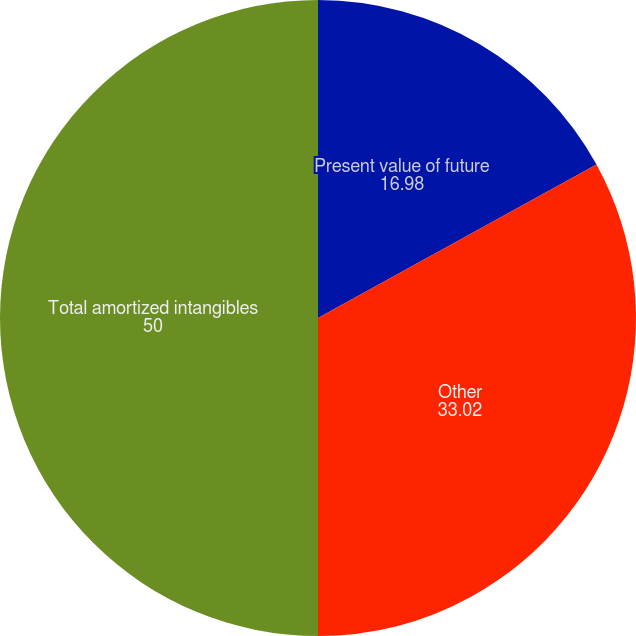<chart> <loc_0><loc_0><loc_500><loc_500><pie_chart><fcel>Present value of future<fcel>Other<fcel>Total amortized intangibles<nl><fcel>16.98%<fcel>33.02%<fcel>50.0%<nl></chart> 